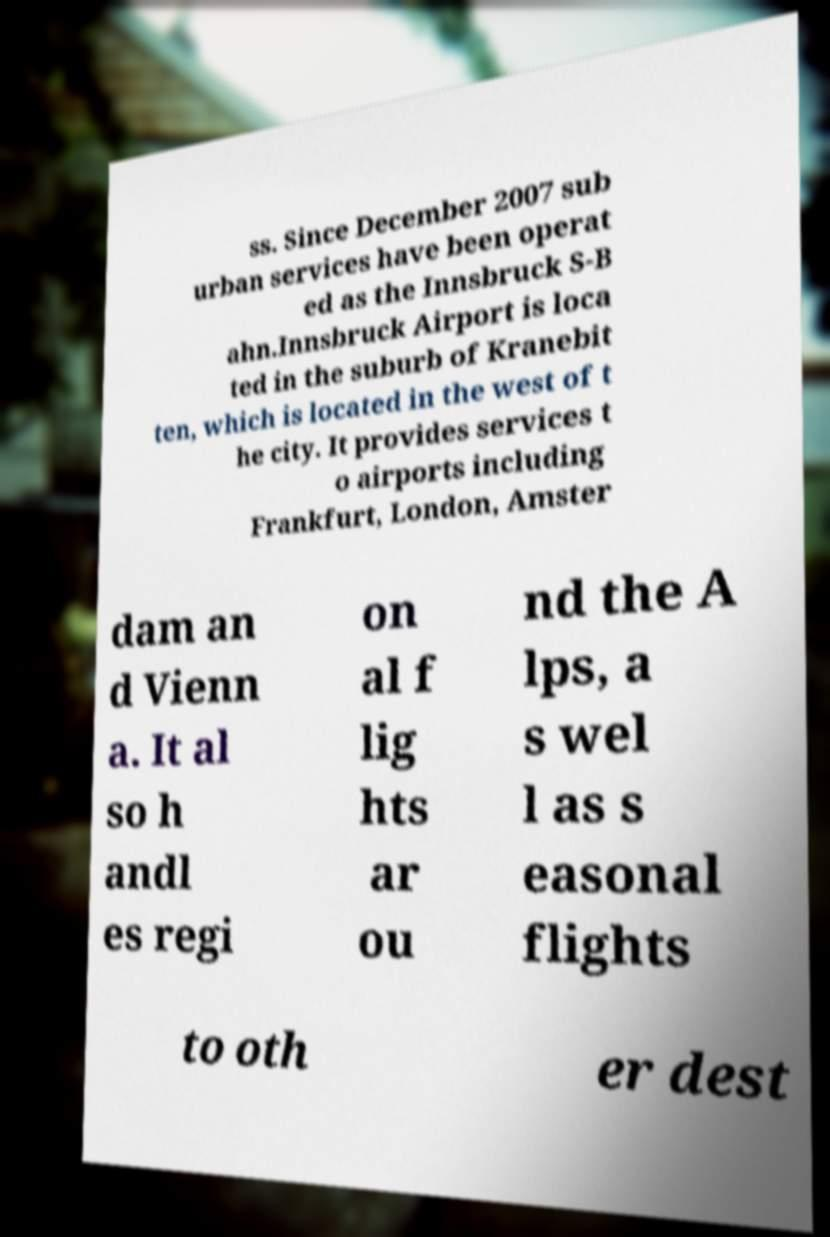There's text embedded in this image that I need extracted. Can you transcribe it verbatim? ss. Since December 2007 sub urban services have been operat ed as the Innsbruck S-B ahn.Innsbruck Airport is loca ted in the suburb of Kranebit ten, which is located in the west of t he city. It provides services t o airports including Frankfurt, London, Amster dam an d Vienn a. It al so h andl es regi on al f lig hts ar ou nd the A lps, a s wel l as s easonal flights to oth er dest 